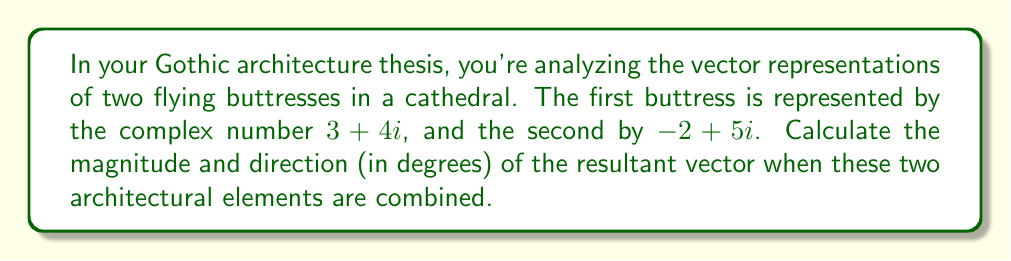Solve this math problem. To solve this problem, we'll follow these steps:

1) First, we need to add the two complex numbers representing the buttresses:
   $$(3 + 4i) + (-2 + 5i) = (3 - 2) + (4 + 5)i = 1 + 9i$$

2) Now, we have a resultant vector represented by the complex number $1 + 9i$. Let's calculate its magnitude and direction.

3) Magnitude:
   The magnitude of a complex number $a + bi$ is given by $\sqrt{a^2 + b^2}$.
   $$|1 + 9i| = \sqrt{1^2 + 9^2} = \sqrt{82}$$

4) Direction:
   The direction (argument) of a complex number $a + bi$ is given by $\tan^{-1}(\frac{b}{a})$.
   However, we need to be careful about which quadrant the vector is in.

   In this case, $\tan^{-1}(\frac{9}{1}) = 83.66°$

   Since both the real and imaginary parts are positive, the vector is in the first quadrant, so this angle is correct.

[asy]
import graph;
size(200);
real f(real x) {return 9*x;}
xaxis("Re",arrow=Arrow);
yaxis("Im",arrow=Arrow);
draw((0,0)--(1,9),blue,arrow=Arrow);
label("1+9i",(1,9),NE);
draw((0,0)--(1,0),dashed);
draw((1,0)--(1,9),dashed);
label("1",(0.5,0),S);
label("9",(1,4.5),E);
draw(arc((0,0),0.5,0,83.66),arrow=Arrow);
label("$83.66°$",(0.3,0.3),NE);
[/asy]
Answer: Magnitude: $\sqrt{82}$
Direction: $83.66°$ 